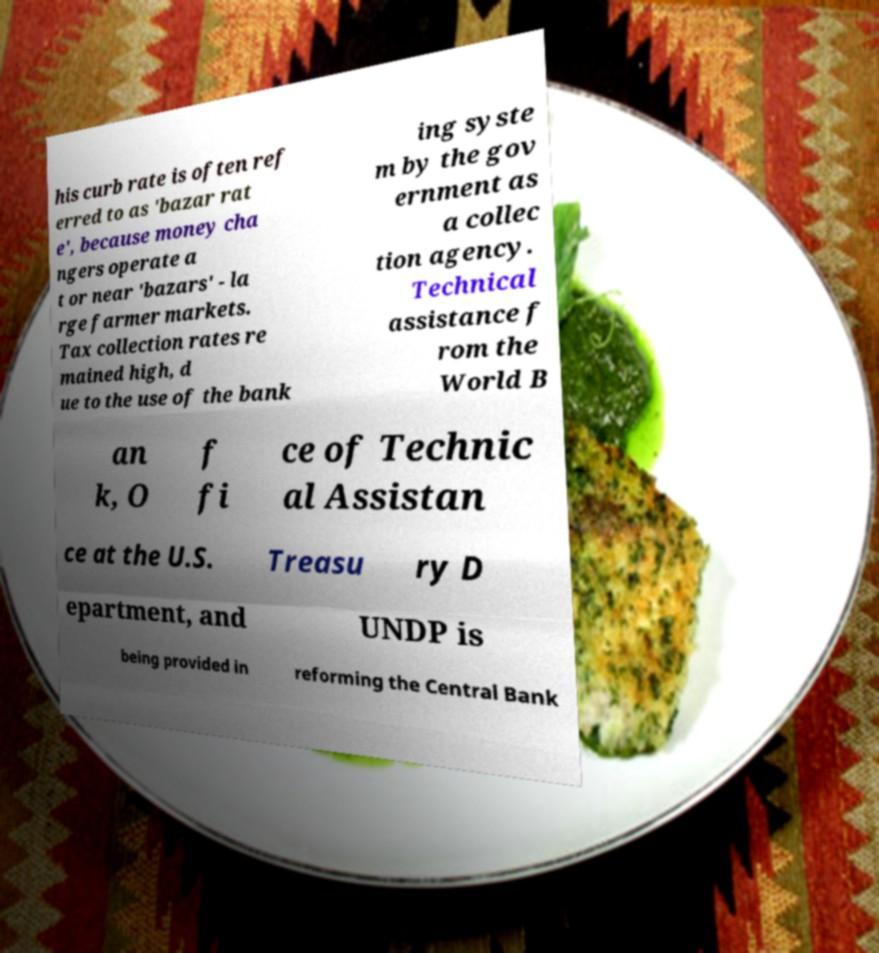For documentation purposes, I need the text within this image transcribed. Could you provide that? his curb rate is often ref erred to as 'bazar rat e', because money cha ngers operate a t or near 'bazars' - la rge farmer markets. Tax collection rates re mained high, d ue to the use of the bank ing syste m by the gov ernment as a collec tion agency. Technical assistance f rom the World B an k, O f fi ce of Technic al Assistan ce at the U.S. Treasu ry D epartment, and UNDP is being provided in reforming the Central Bank 